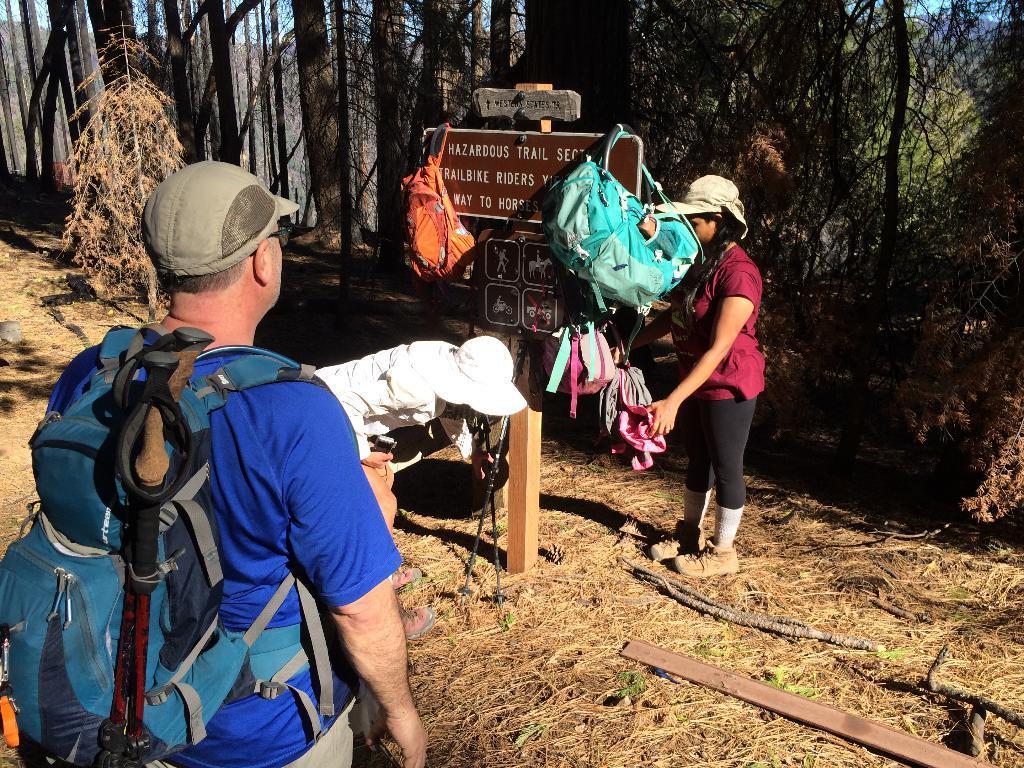Describe this image in one or two sentences. There are three person. The two persons are standing. They are wearing a cap. On the left side of the person is wearing a bag. In the center side of the person is sitting like squat position. We can see in background trees,wooden stick and name board. 